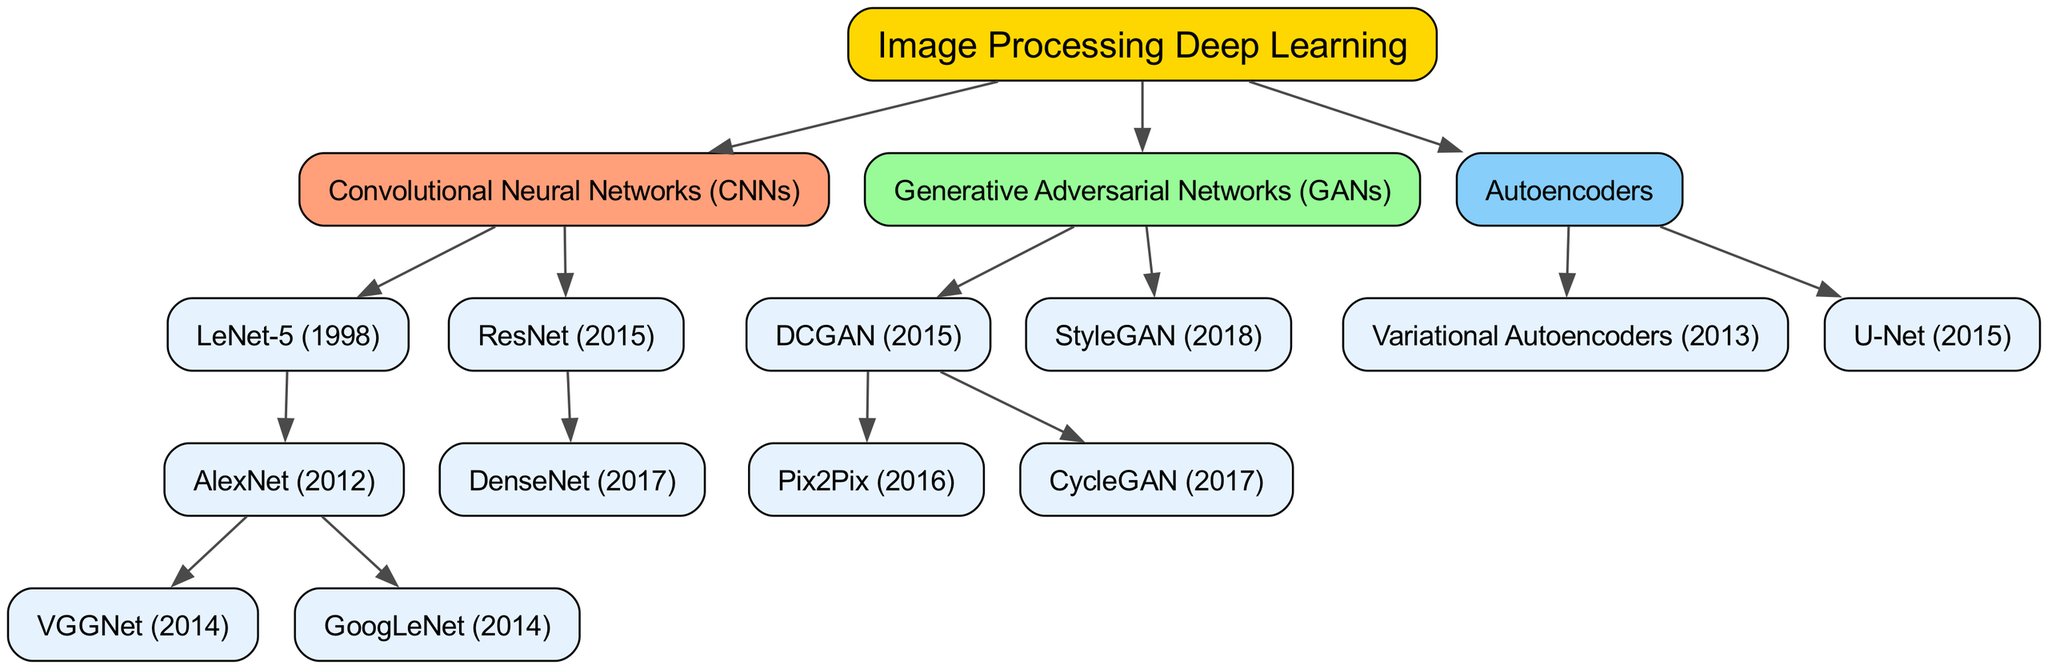What is the root of the family tree? The root node of the diagram represents the highest level in the hierarchy, which is "Image Processing Deep Learning."
Answer: Image Processing Deep Learning How many children does Convolutional Neural Networks have? By examining the "Convolutional Neural Networks" node, there are two children listed under it: "LeNet-5" and "ResNet."
Answer: 2 Which algorithm was released first, VGGNet or GoogLeNet? To answer this, we can look at the years associated with each algorithm: VGGNet is from 2014 and GoogLeNet is also from 2014; however, VGGNet is listed before GoogLeNet in the hierarchy.
Answer: VGGNet What type of neural network is DenseNet? DenseNet is listed as a child of "ResNet," which falls under the category of "Convolutional Neural Networks." It is specifically a type of CNN.
Answer: Convolutional Neural Network Which algorithm is a descendant of both DCGAN and StyleGAN? By analyzing the tree structure, both "DCGAN" and "StyleGAN" are under the parent "Generative Adversarial Networks," but none of them has a direct relationship or a shared descendant. Therefore, there are no common descendants.
Answer: None What distinguishes U-Net among the Autoencoders? U-Net is noted as a unique type of Autoencoder within the diagram, which stands distinct from "Variational Autoencoders." Its main distinction is its architecture that is particularly suited for semantic segmentation tasks.
Answer: U-Net How many algorithms are listed under Generative Adversarial Networks? Looking at the "Generative Adversarial Networks" section, there are three algorithms: "DCGAN," "StyleGAN," and one more; DCGAN has two children (Pix2Pix and CycleGAN), totaling five algorithms.
Answer: 5 What year was ResNet introduced? The diagram clearly states that ResNet was introduced in 2015, which can be noted directly from the node information.
Answer: 2015 Which algorithm is the only child of the Autoencoders? The diagram indicates that both "Variational Autoencoders" and "U-Net" are children of the "Autoencoders" category, but there is no single direct child under Autoencoders. Thus, it must be a collective consideration.
Answer: None 